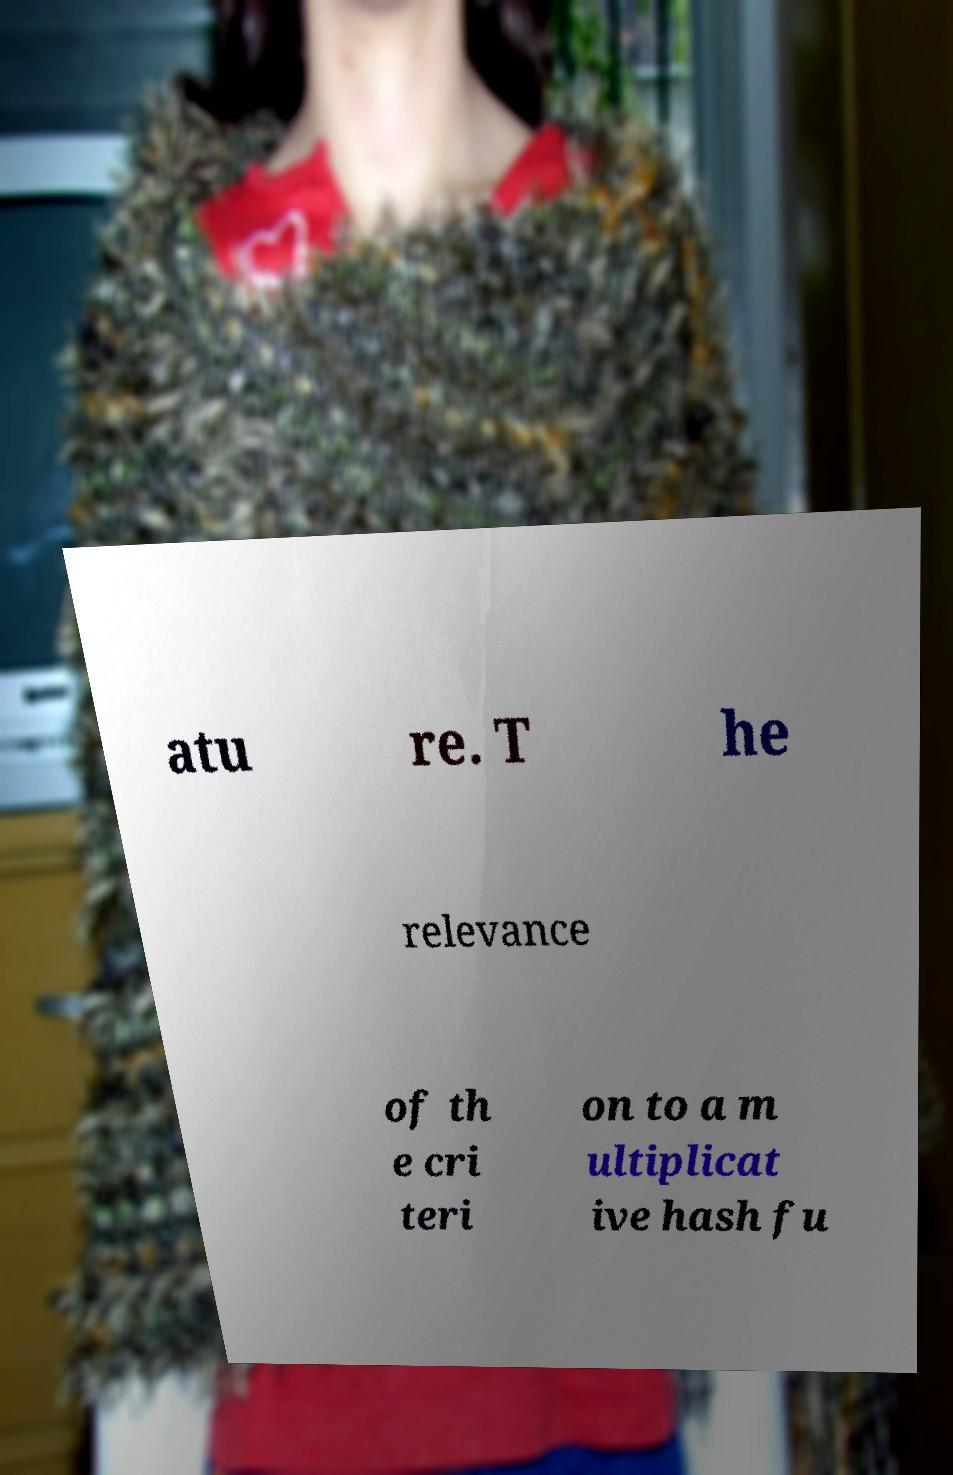What messages or text are displayed in this image? I need them in a readable, typed format. atu re. T he relevance of th e cri teri on to a m ultiplicat ive hash fu 